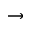Convert formula to latex. <formula><loc_0><loc_0><loc_500><loc_500>\rightarrow</formula> 